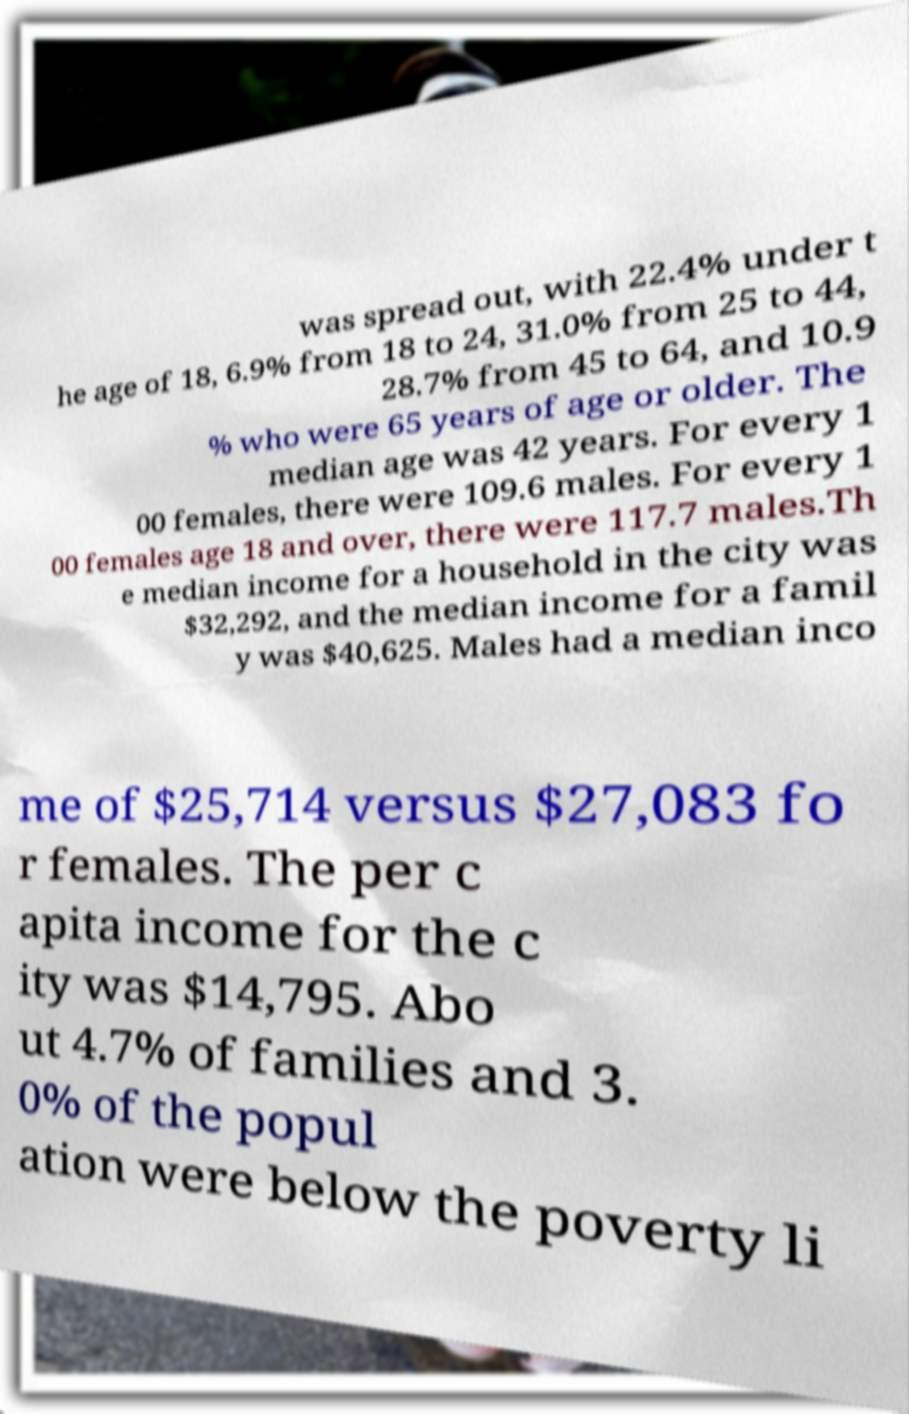For documentation purposes, I need the text within this image transcribed. Could you provide that? was spread out, with 22.4% under t he age of 18, 6.9% from 18 to 24, 31.0% from 25 to 44, 28.7% from 45 to 64, and 10.9 % who were 65 years of age or older. The median age was 42 years. For every 1 00 females, there were 109.6 males. For every 1 00 females age 18 and over, there were 117.7 males.Th e median income for a household in the city was $32,292, and the median income for a famil y was $40,625. Males had a median inco me of $25,714 versus $27,083 fo r females. The per c apita income for the c ity was $14,795. Abo ut 4.7% of families and 3. 0% of the popul ation were below the poverty li 